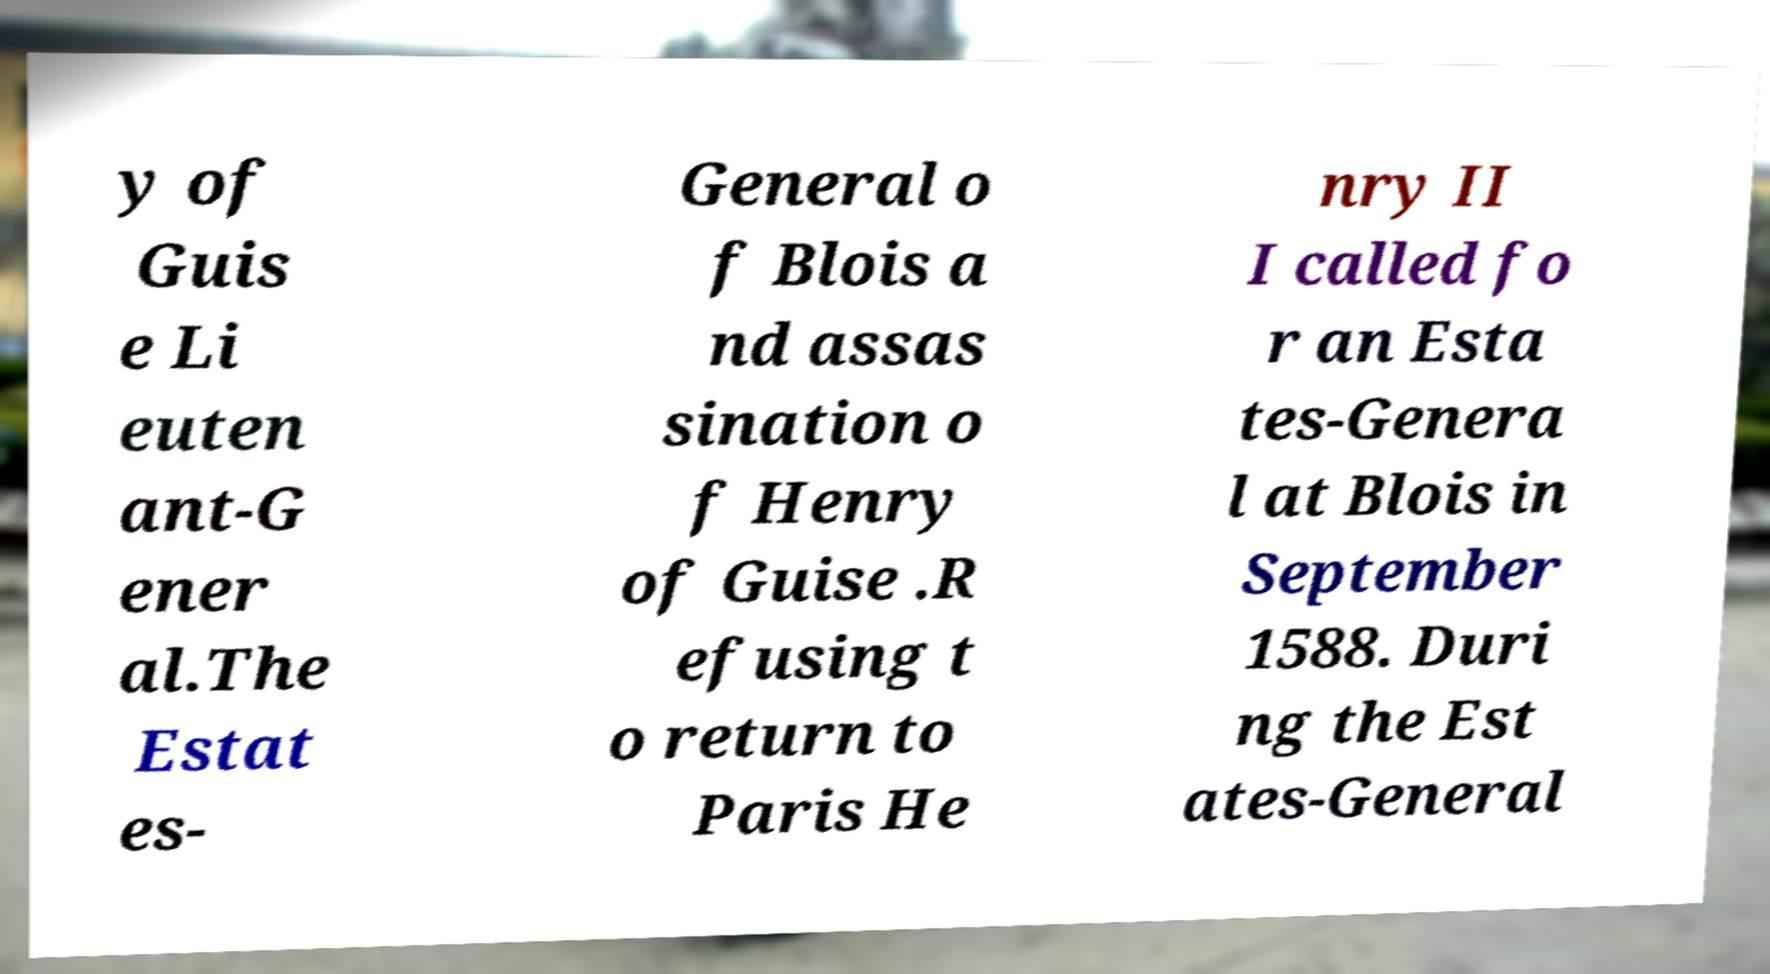Can you read and provide the text displayed in the image?This photo seems to have some interesting text. Can you extract and type it out for me? y of Guis e Li euten ant-G ener al.The Estat es- General o f Blois a nd assas sination o f Henry of Guise .R efusing t o return to Paris He nry II I called fo r an Esta tes-Genera l at Blois in September 1588. Duri ng the Est ates-General 